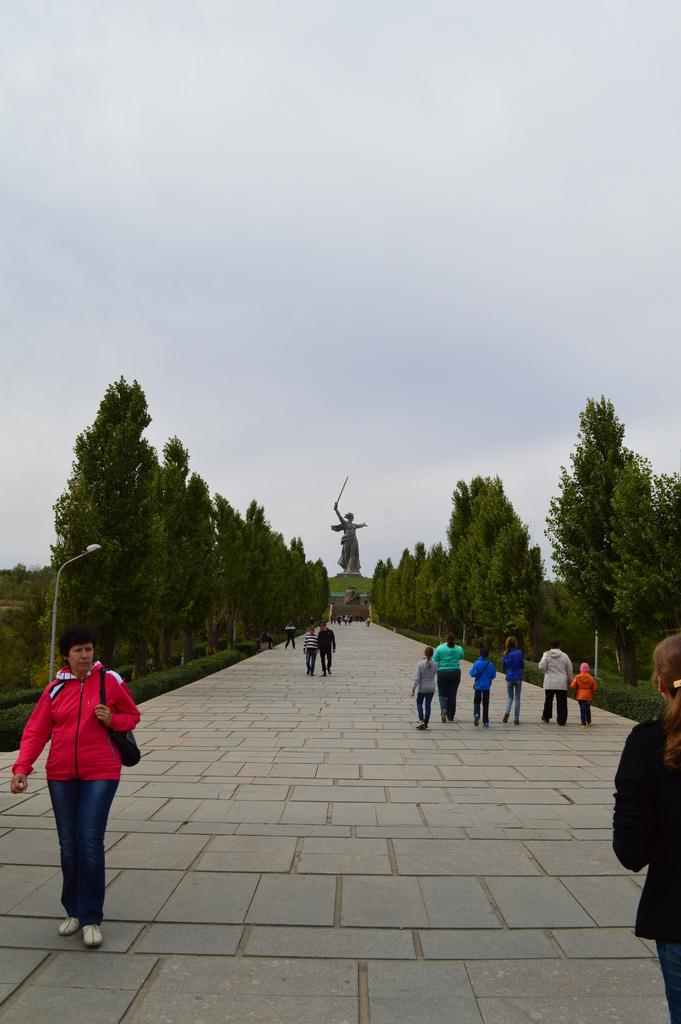What is the main subject in the image? There is a statue in the image. What other objects can be seen in the image? Street poles, street lights, and trees are visible in the image. What is happening on the floor in the image? There are persons walking on the floor in the image. What is visible in the background of the image? The sky is visible in the background of the image. What can be seen in the sky? Clouds are present in the sky. What type of cord is being used by the statue to express love in the image? There is no cord or expression of love present in the image; it features a statue, street poles, street lights, trees, persons walking, the sky, and clouds. 